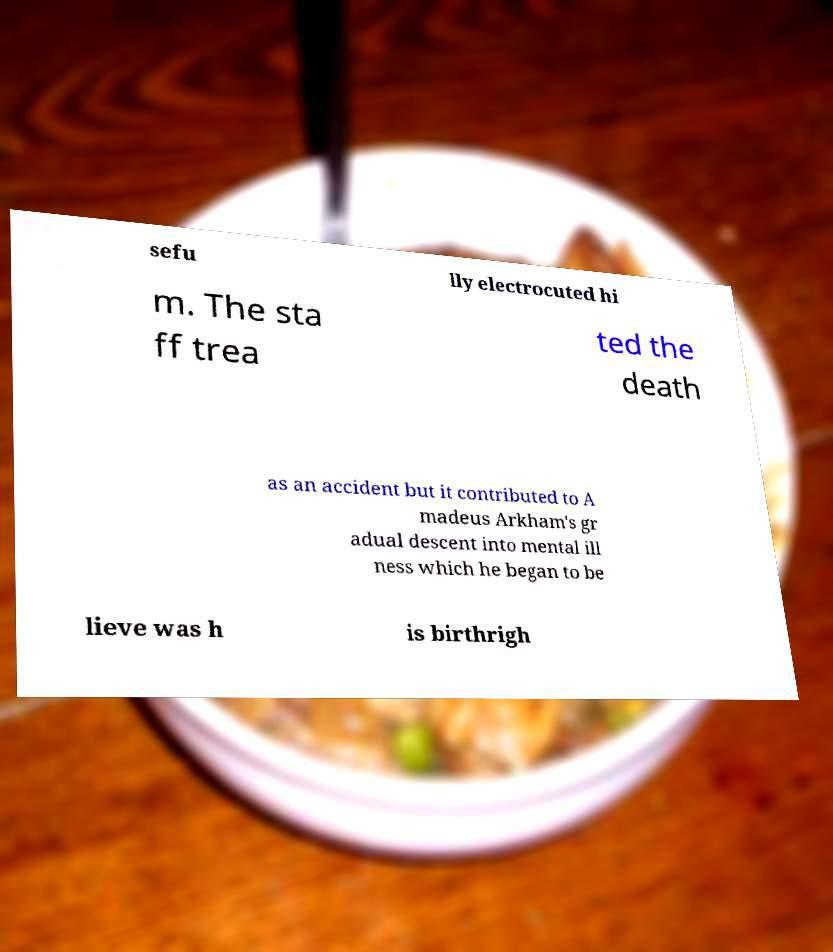Can you read and provide the text displayed in the image?This photo seems to have some interesting text. Can you extract and type it out for me? sefu lly electrocuted hi m. The sta ff trea ted the death as an accident but it contributed to A madeus Arkham's gr adual descent into mental ill ness which he began to be lieve was h is birthrigh 